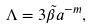<formula> <loc_0><loc_0><loc_500><loc_500>\Lambda = 3 \tilde { \beta } a ^ { - m } ,</formula> 